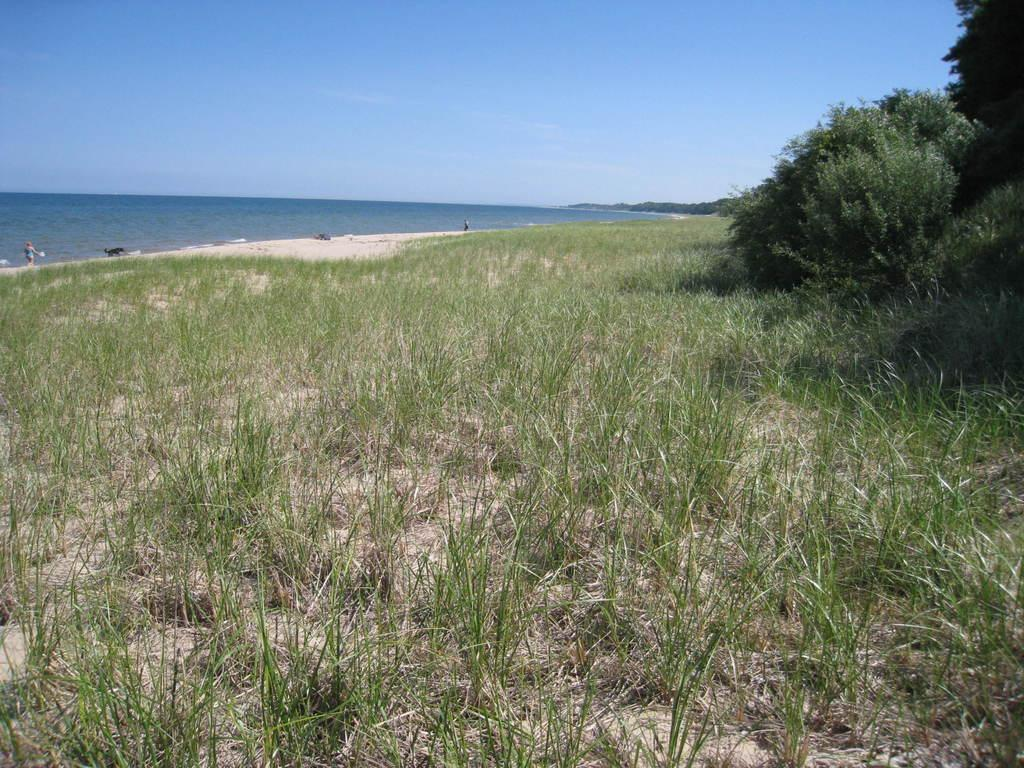What type of vegetation covers the land in the image? The land in the image is covered with grass. Where are the trees located in the image? The trees are on the right side of the image. What can be seen in the background of the image? There is a water surface visible in the background of the image. What type of noise can be heard coming from the trees in the image? There is no indication of any noise in the image, as it only shows a land covered with grass, trees on the right side, and a water surface in the background. 